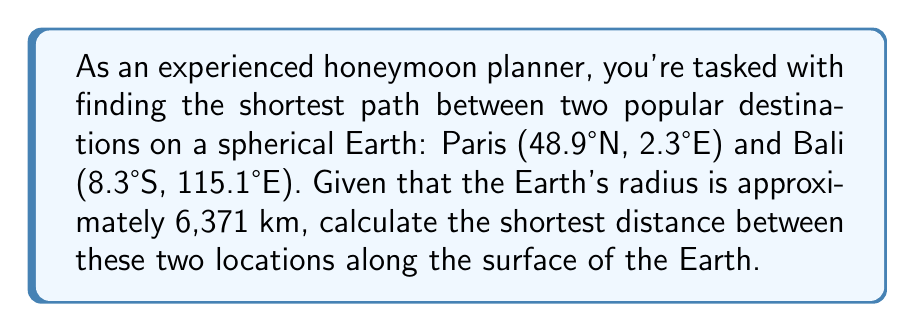What is the answer to this math problem? To solve this problem, we'll use the great-circle distance formula, which gives the shortest path between two points on a sphere. The steps are as follows:

1. Convert the latitudes and longitudes to radians:
   Paris: $\phi_1 = 48.9° \times \frac{\pi}{180} = 0.8535$ rad, $\lambda_1 = 2.3° \times \frac{\pi}{180} = 0.0401$ rad
   Bali: $\phi_2 = -8.3° \times \frac{\pi}{180} = -0.1449$ rad, $\lambda_2 = 115.1° \times \frac{\pi}{180} = 2.0087$ rad

2. Calculate the central angle $\Delta\sigma$ using the Haversine formula:
   $$\Delta\sigma = 2 \arcsin\left(\sqrt{\sin^2\left(\frac{\phi_2 - \phi_1}{2}\right) + \cos\phi_1 \cos\phi_2 \sin^2\left(\frac{\lambda_2 - \lambda_1}{2}\right)}\right)$$

3. Substitute the values:
   $$\Delta\sigma = 2 \arcsin\left(\sqrt{\sin^2\left(\frac{-0.1449 - 0.8535}{2}\right) + \cos(0.8535) \cos(-0.1449) \sin^2\left(\frac{2.0087 - 0.0401}{2}\right)}\right)$$

4. Calculate:
   $$\Delta\sigma = 2 \arcsin(\sqrt{0.2500 + 0.5231 \times 0.9896 \times 0.4774}) = 2 \arcsin(\sqrt{0.7464}) = 2 \times 1.0955 = 2.1910$$

5. The distance $d$ is then calculated by multiplying the central angle by the Earth's radius:
   $$d = 6371 \times 2.1910 = 13,958.86 \text{ km}$$

Thus, the shortest distance between Paris and Bali along the Earth's surface is approximately 13,959 km.
Answer: 13,959 km 